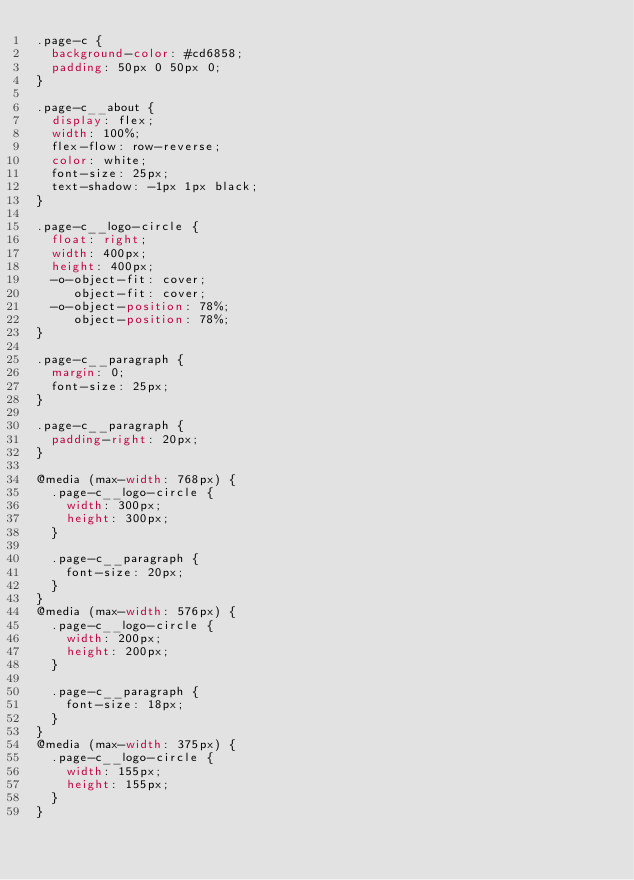Convert code to text. <code><loc_0><loc_0><loc_500><loc_500><_CSS_>.page-c {
  background-color: #cd6858;
  padding: 50px 0 50px 0;
}

.page-c__about {
  display: flex;
  width: 100%;
  flex-flow: row-reverse;
  color: white;
  font-size: 25px;
  text-shadow: -1px 1px black;
}

.page-c__logo-circle {
  float: right;
  width: 400px;
  height: 400px;
  -o-object-fit: cover;
     object-fit: cover;
  -o-object-position: 78%;
     object-position: 78%;
}

.page-c__paragraph {
  margin: 0;
  font-size: 25px;
}

.page-c__paragraph {
  padding-right: 20px;
}

@media (max-width: 768px) {
  .page-c__logo-circle {
    width: 300px;
    height: 300px;
  }

  .page-c__paragraph {
    font-size: 20px;
  }
}
@media (max-width: 576px) {
  .page-c__logo-circle {
    width: 200px;
    height: 200px;
  }

  .page-c__paragraph {
    font-size: 18px;
  }
}
@media (max-width: 375px) {
  .page-c__logo-circle {
    width: 155px;
    height: 155px;
  }
}
</code> 